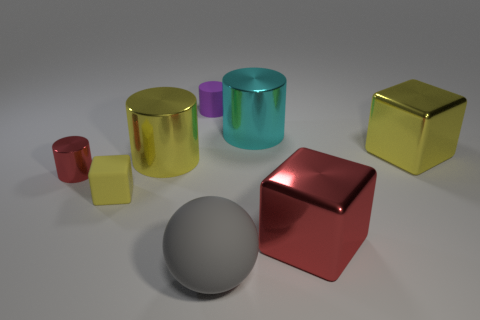Add 2 tiny metal objects. How many objects exist? 10 Subtract all cubes. How many objects are left? 5 Subtract 1 red cylinders. How many objects are left? 7 Subtract all purple rubber cylinders. Subtract all tiny rubber blocks. How many objects are left? 6 Add 2 large cyan shiny cylinders. How many large cyan shiny cylinders are left? 3 Add 5 tiny red cylinders. How many tiny red cylinders exist? 6 